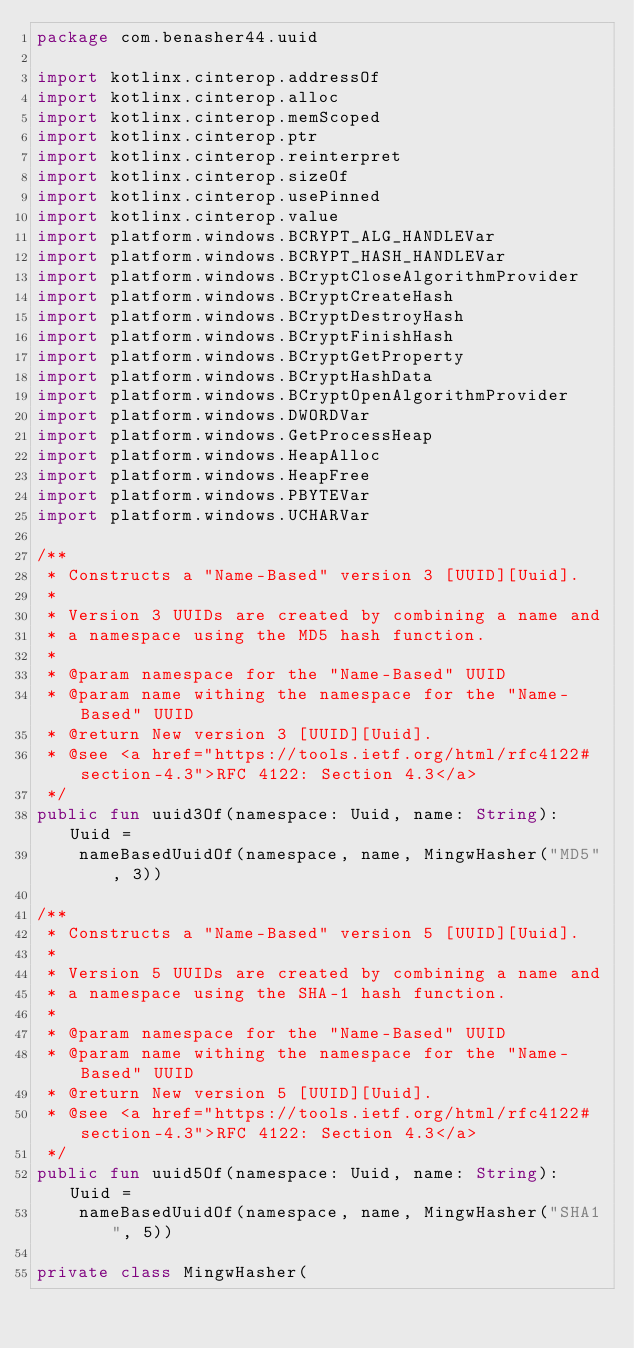<code> <loc_0><loc_0><loc_500><loc_500><_Kotlin_>package com.benasher44.uuid

import kotlinx.cinterop.addressOf
import kotlinx.cinterop.alloc
import kotlinx.cinterop.memScoped
import kotlinx.cinterop.ptr
import kotlinx.cinterop.reinterpret
import kotlinx.cinterop.sizeOf
import kotlinx.cinterop.usePinned
import kotlinx.cinterop.value
import platform.windows.BCRYPT_ALG_HANDLEVar
import platform.windows.BCRYPT_HASH_HANDLEVar
import platform.windows.BCryptCloseAlgorithmProvider
import platform.windows.BCryptCreateHash
import platform.windows.BCryptDestroyHash
import platform.windows.BCryptFinishHash
import platform.windows.BCryptGetProperty
import platform.windows.BCryptHashData
import platform.windows.BCryptOpenAlgorithmProvider
import platform.windows.DWORDVar
import platform.windows.GetProcessHeap
import platform.windows.HeapAlloc
import platform.windows.HeapFree
import platform.windows.PBYTEVar
import platform.windows.UCHARVar

/**
 * Constructs a "Name-Based" version 3 [UUID][Uuid].
 *
 * Version 3 UUIDs are created by combining a name and
 * a namespace using the MD5 hash function.
 *
 * @param namespace for the "Name-Based" UUID
 * @param name withing the namespace for the "Name-Based" UUID
 * @return New version 3 [UUID][Uuid].
 * @see <a href="https://tools.ietf.org/html/rfc4122#section-4.3">RFC 4122: Section 4.3</a>
 */
public fun uuid3Of(namespace: Uuid, name: String): Uuid =
    nameBasedUuidOf(namespace, name, MingwHasher("MD5", 3))

/**
 * Constructs a "Name-Based" version 5 [UUID][Uuid].
 *
 * Version 5 UUIDs are created by combining a name and
 * a namespace using the SHA-1 hash function.
 *
 * @param namespace for the "Name-Based" UUID
 * @param name withing the namespace for the "Name-Based" UUID
 * @return New version 5 [UUID][Uuid].
 * @see <a href="https://tools.ietf.org/html/rfc4122#section-4.3">RFC 4122: Section 4.3</a>
 */
public fun uuid5Of(namespace: Uuid, name: String): Uuid =
    nameBasedUuidOf(namespace, name, MingwHasher("SHA1", 5))

private class MingwHasher(</code> 